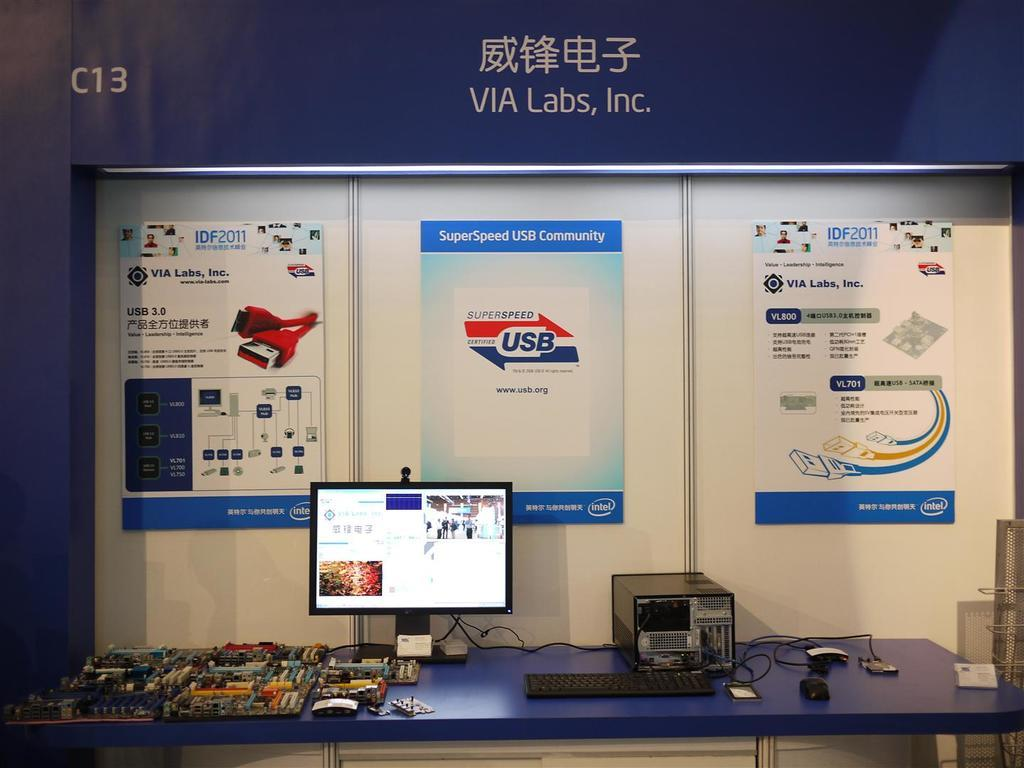<image>
Render a clear and concise summary of the photo. Via labs, Inc has a display with posters and computers on a table 